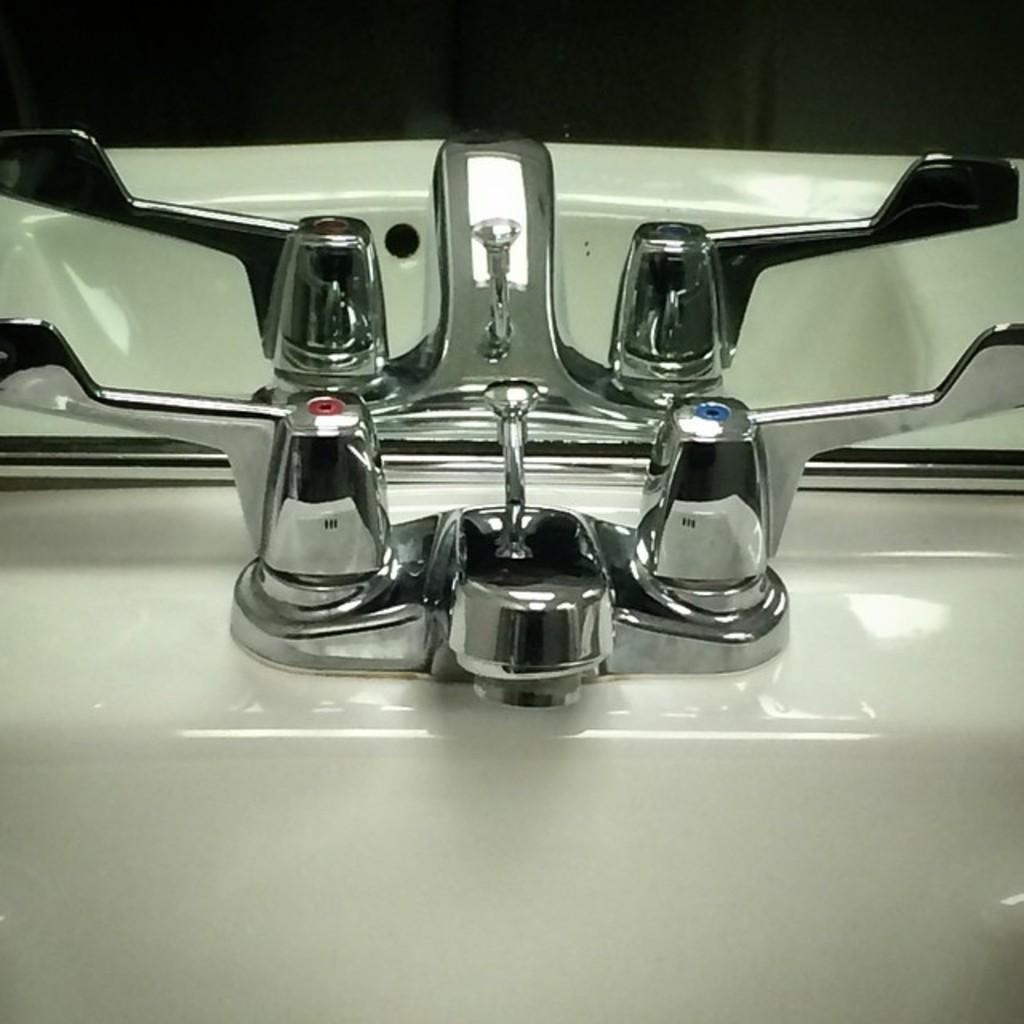What is the main fixture in the image? There is a sink in the image. What is used to control the flow of water in the sink? There are taps in the image. What can be seen in the background of the image? There is a mirror in the background of the image. What type of key is used to unlock the harmony in the image? There is no key or harmony present in the image; it features a sink with taps and a mirror in the background. 